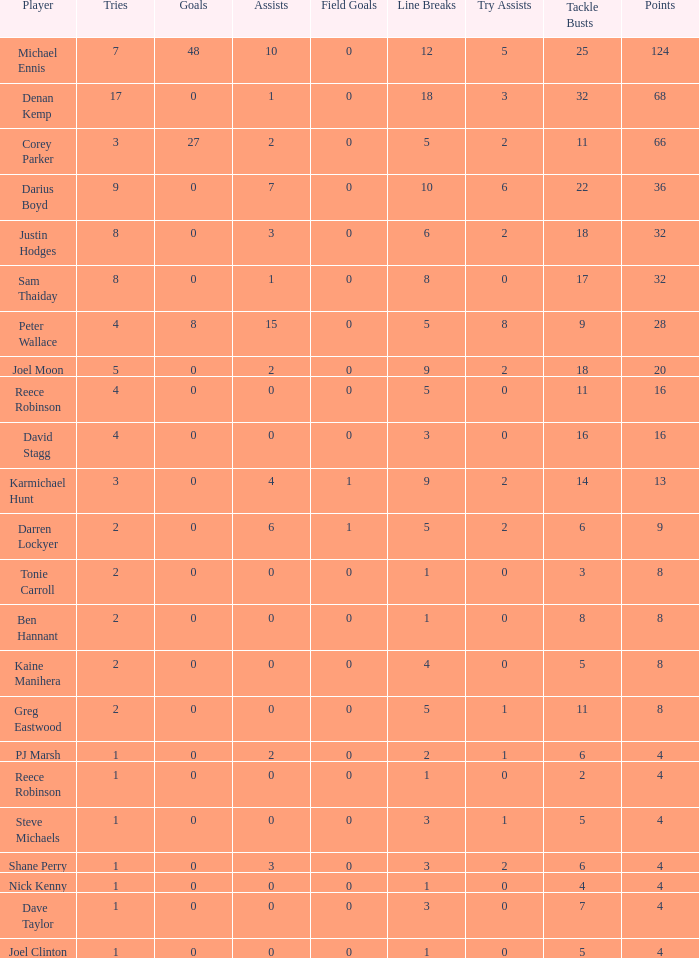What is the total number of field goals of Denan Kemp, who has more than 4 tries, more than 32 points, and 0 goals? 1.0. 